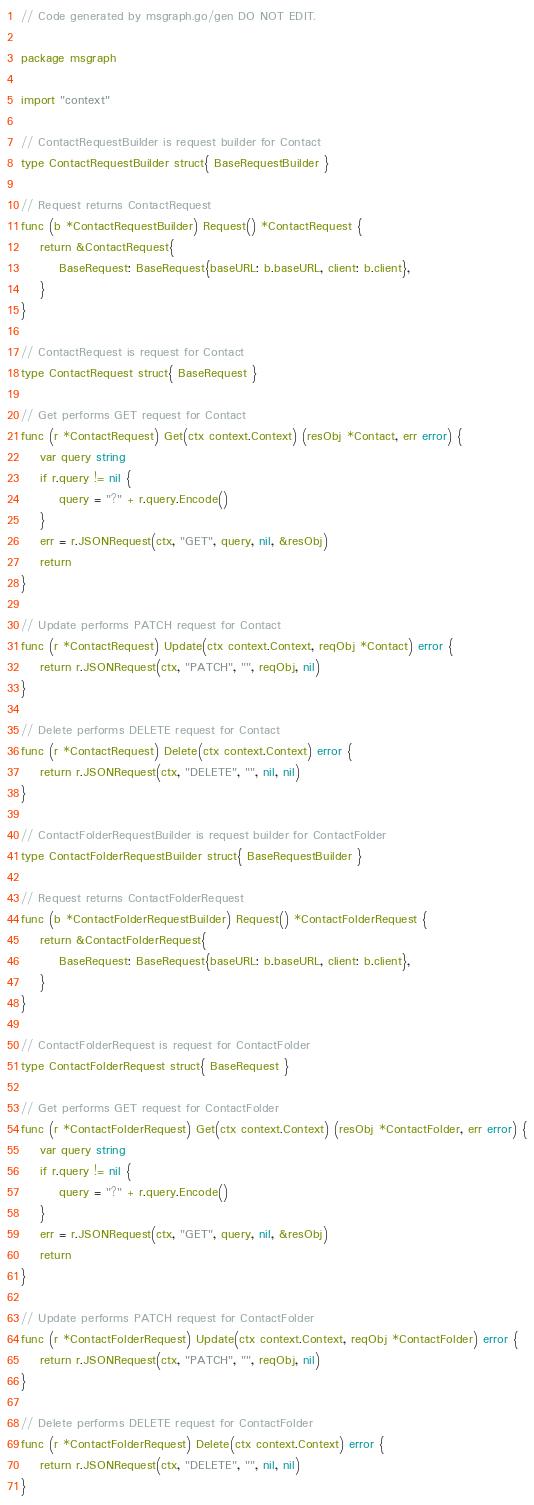<code> <loc_0><loc_0><loc_500><loc_500><_Go_>// Code generated by msgraph.go/gen DO NOT EDIT.

package msgraph

import "context"

// ContactRequestBuilder is request builder for Contact
type ContactRequestBuilder struct{ BaseRequestBuilder }

// Request returns ContactRequest
func (b *ContactRequestBuilder) Request() *ContactRequest {
	return &ContactRequest{
		BaseRequest: BaseRequest{baseURL: b.baseURL, client: b.client},
	}
}

// ContactRequest is request for Contact
type ContactRequest struct{ BaseRequest }

// Get performs GET request for Contact
func (r *ContactRequest) Get(ctx context.Context) (resObj *Contact, err error) {
	var query string
	if r.query != nil {
		query = "?" + r.query.Encode()
	}
	err = r.JSONRequest(ctx, "GET", query, nil, &resObj)
	return
}

// Update performs PATCH request for Contact
func (r *ContactRequest) Update(ctx context.Context, reqObj *Contact) error {
	return r.JSONRequest(ctx, "PATCH", "", reqObj, nil)
}

// Delete performs DELETE request for Contact
func (r *ContactRequest) Delete(ctx context.Context) error {
	return r.JSONRequest(ctx, "DELETE", "", nil, nil)
}

// ContactFolderRequestBuilder is request builder for ContactFolder
type ContactFolderRequestBuilder struct{ BaseRequestBuilder }

// Request returns ContactFolderRequest
func (b *ContactFolderRequestBuilder) Request() *ContactFolderRequest {
	return &ContactFolderRequest{
		BaseRequest: BaseRequest{baseURL: b.baseURL, client: b.client},
	}
}

// ContactFolderRequest is request for ContactFolder
type ContactFolderRequest struct{ BaseRequest }

// Get performs GET request for ContactFolder
func (r *ContactFolderRequest) Get(ctx context.Context) (resObj *ContactFolder, err error) {
	var query string
	if r.query != nil {
		query = "?" + r.query.Encode()
	}
	err = r.JSONRequest(ctx, "GET", query, nil, &resObj)
	return
}

// Update performs PATCH request for ContactFolder
func (r *ContactFolderRequest) Update(ctx context.Context, reqObj *ContactFolder) error {
	return r.JSONRequest(ctx, "PATCH", "", reqObj, nil)
}

// Delete performs DELETE request for ContactFolder
func (r *ContactFolderRequest) Delete(ctx context.Context) error {
	return r.JSONRequest(ctx, "DELETE", "", nil, nil)
}
</code> 